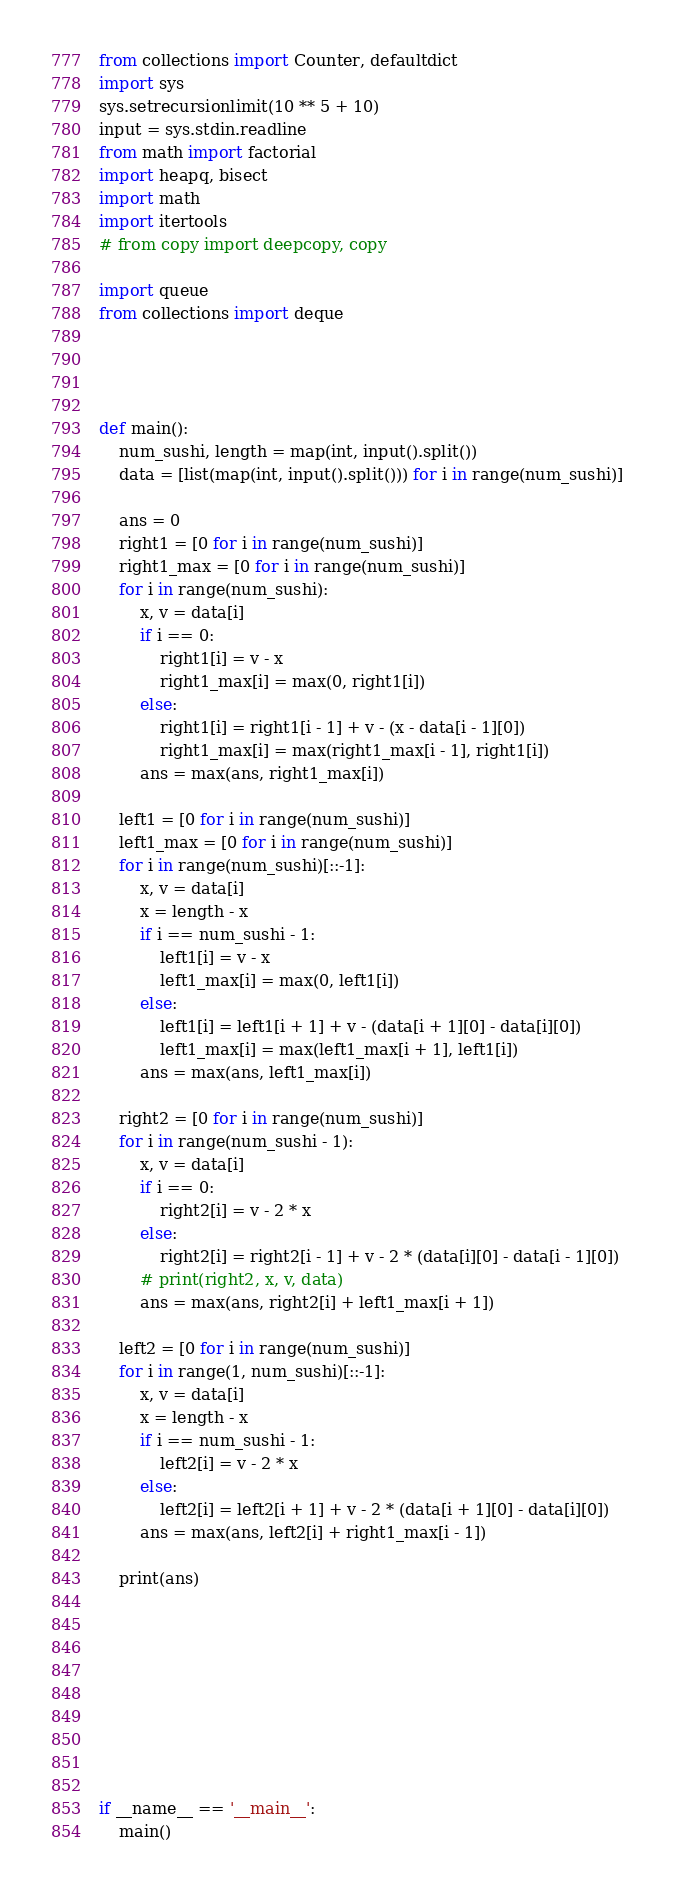<code> <loc_0><loc_0><loc_500><loc_500><_Python_>from collections import Counter, defaultdict
import sys
sys.setrecursionlimit(10 ** 5 + 10)
input = sys.stdin.readline
from math import factorial
import heapq, bisect
import math
import itertools
# from copy import deepcopy, copy

import queue
from collections import deque




def main():
    num_sushi, length = map(int, input().split())
    data = [list(map(int, input().split())) for i in range(num_sushi)]

    ans = 0
    right1 = [0 for i in range(num_sushi)]
    right1_max = [0 for i in range(num_sushi)]
    for i in range(num_sushi):
        x, v = data[i]
        if i == 0:
            right1[i] = v - x
            right1_max[i] = max(0, right1[i])
        else:
            right1[i] = right1[i - 1] + v - (x - data[i - 1][0])
            right1_max[i] = max(right1_max[i - 1], right1[i])
        ans = max(ans, right1_max[i])

    left1 = [0 for i in range(num_sushi)]
    left1_max = [0 for i in range(num_sushi)]
    for i in range(num_sushi)[::-1]:
        x, v = data[i]
        x = length - x
        if i == num_sushi - 1:
            left1[i] = v - x
            left1_max[i] = max(0, left1[i])
        else:
            left1[i] = left1[i + 1] + v - (data[i + 1][0] - data[i][0])
            left1_max[i] = max(left1_max[i + 1], left1[i])
        ans = max(ans, left1_max[i])

    right2 = [0 for i in range(num_sushi)]
    for i in range(num_sushi - 1):
        x, v = data[i]
        if i == 0:
            right2[i] = v - 2 * x
        else:
            right2[i] = right2[i - 1] + v - 2 * (data[i][0] - data[i - 1][0])
        # print(right2, x, v, data)
        ans = max(ans, right2[i] + left1_max[i + 1])

    left2 = [0 for i in range(num_sushi)]
    for i in range(1, num_sushi)[::-1]:
        x, v = data[i]
        x = length - x
        if i == num_sushi - 1:
            left2[i] = v - 2 * x
        else:
            left2[i] = left2[i + 1] + v - 2 * (data[i + 1][0] - data[i][0])
        ans = max(ans, left2[i] + right1_max[i - 1])

    print(ans)









if __name__ == '__main__':
    main()
</code> 